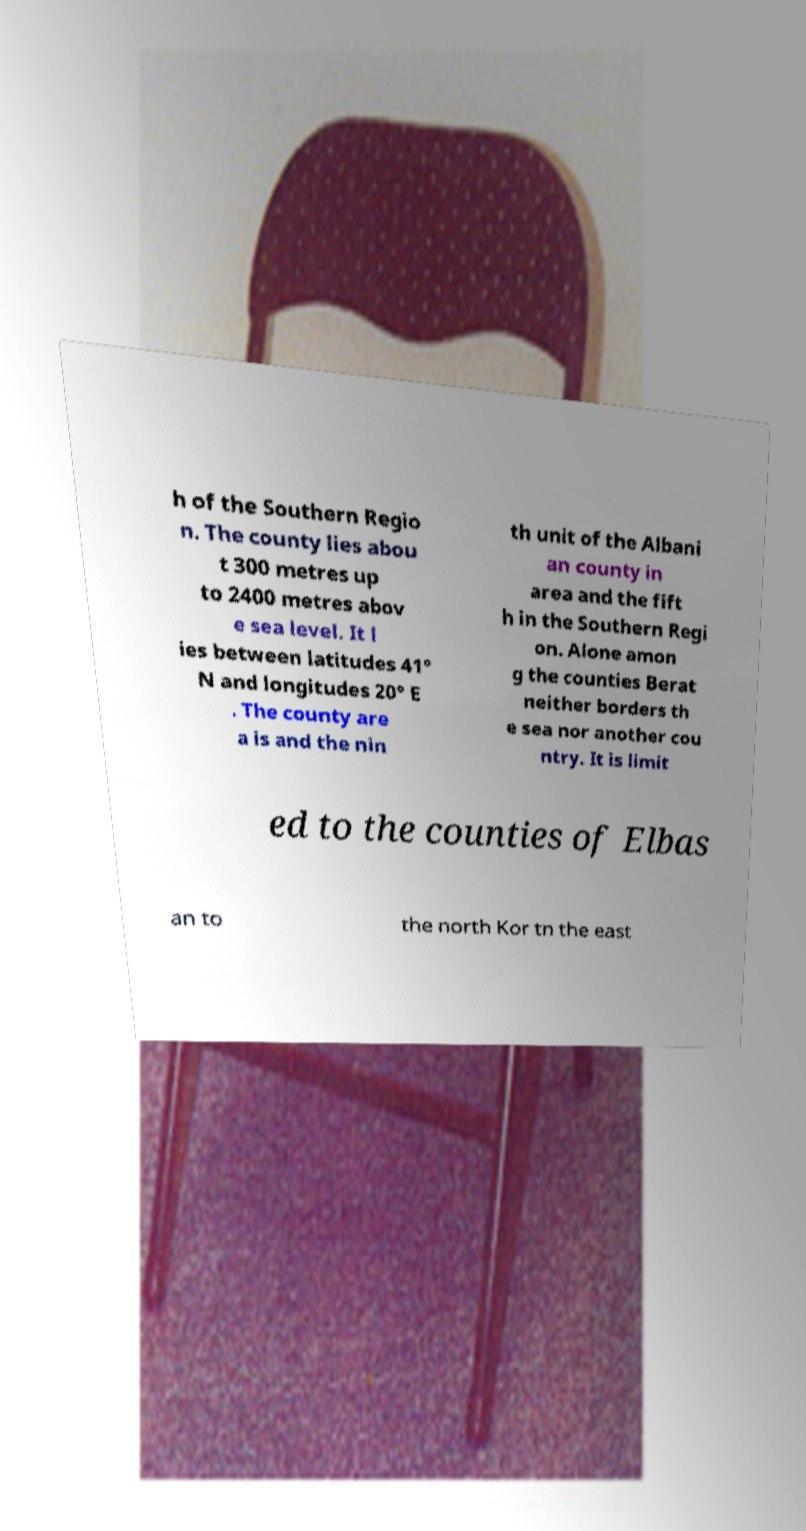There's text embedded in this image that I need extracted. Can you transcribe it verbatim? h of the Southern Regio n. The county lies abou t 300 metres up to 2400 metres abov e sea level. It l ies between latitudes 41° N and longitudes 20° E . The county are a is and the nin th unit of the Albani an county in area and the fift h in the Southern Regi on. Alone amon g the counties Berat neither borders th e sea nor another cou ntry. It is limit ed to the counties of Elbas an to the north Kor tn the east 